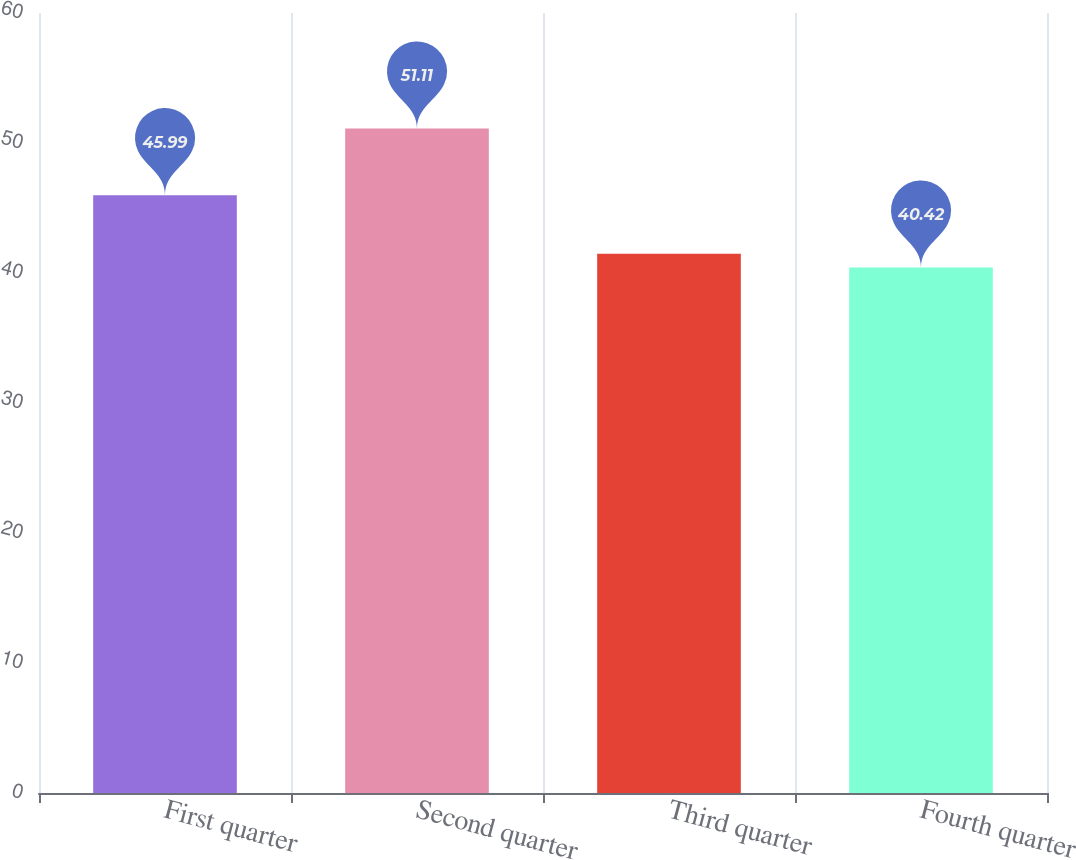<chart> <loc_0><loc_0><loc_500><loc_500><bar_chart><fcel>First quarter<fcel>Second quarter<fcel>Third quarter<fcel>Fourth quarter<nl><fcel>45.99<fcel>51.11<fcel>41.49<fcel>40.42<nl></chart> 